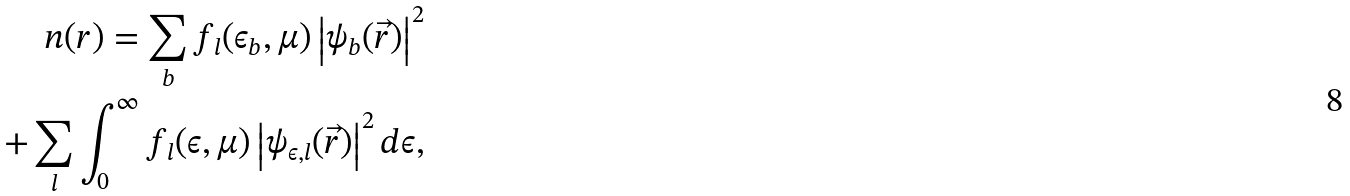<formula> <loc_0><loc_0><loc_500><loc_500>n ( r ) = \sum _ { b } f _ { l } ( \epsilon _ { b } , \mu ) \left | \psi _ { b } ( \vec { r } ) \right | ^ { 2 } \\ + \sum _ { l } \int _ { 0 } ^ { \infty } f _ { l } ( \epsilon , \mu ) \left | \psi _ { \epsilon , l } ( \vec { r } ) \right | ^ { 2 } d \epsilon ,</formula> 